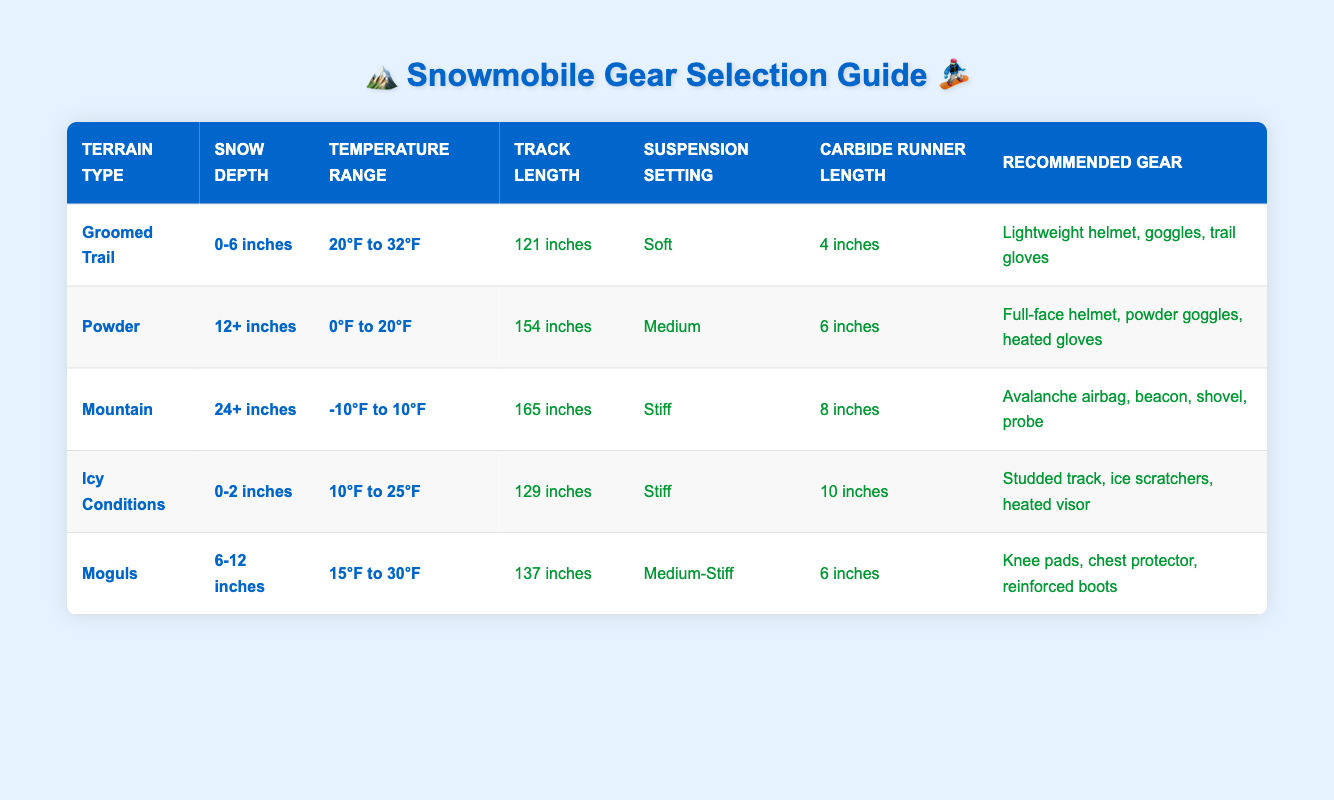What gear is recommended for snowy conditions with 6 to 12 inches of snow depth? Referring to the "Moguls" row in the table, we identify the recommended gear for a snow depth of 6 to 12 inches, which is listed as "Knee pads, chest protector, reinforced boots."
Answer: Knee pads, chest protector, reinforced boots Is the track length for mountain terrain longer than for powder terrain? Comparing the "Track Length" values from the "Mountain" and "Powder" rows, the track length for mountain terrain is 165 inches, while for powder terrain, it is 154 inches. Since 165 inches is greater than 154 inches, the statement is true.
Answer: Yes What is the average carbide runner length for groomed trail and icy conditions? The carbide runner length for groomed trail is 4 inches and for icy conditions is 10 inches. To find the average: (4 + 10) / 2 = 7 inches.
Answer: 7 inches Are the suspension settings for groomed trail and moguls the same? Checking the "Suspension Setting" values, groomed trail has a setting of "Soft," while moguls have "Medium-Stiff." Since the two settings are different, the answer is no.
Answer: No What temperature range is suitable for mountain terrain? The "Temperature Range" for mountain terrain is shown in the table as "-10°F to 10°F." This directly answers the question.
Answer: -10°F to 10°F Which terrain type has the shortest snow depth requirement? Looking at the snow depths for all terrain types, "Icy Conditions" requires snow depth of 0-2 inches, which is lower than the others.
Answer: Icy Conditions If the temperature is between 15°F and 30°F, what terrain types can you ride? Based on the temperature range in the table, the "Moguls" and "Icy Conditions" terrain types fall within this range. "Moguls" covers 15°F to 30°F, and "Icy Conditions" covers 10°F to 25°F, but which one is fully within 15°F to 30°F? Therefore, only Moguls is fully met.
Answer: Moguls Is the recommended gear for powder terrain different from groomed trail terrain? The recommended gear for powder is "Full-face helmet, powder goggles, heated gloves," while for groomed trail, it is "Lightweight helmet, goggles, trail gloves," indicating that they are indeed different.
Answer: Yes What is the total recommended gear items for mountain terrain? The recommended gear for mountain terrain includes four items: "Avalanche airbag, beacon, shovel, probe." This totals to four distinct items.
Answer: 4 items 